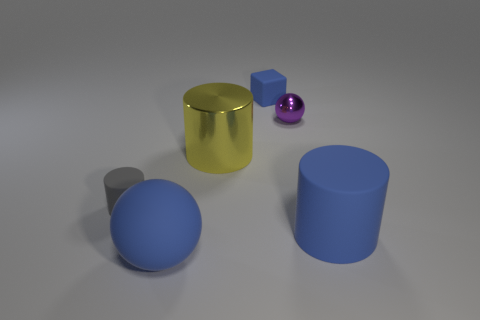Add 1 tiny cylinders. How many objects exist? 7 Subtract all balls. How many objects are left? 4 Subtract all large gray matte balls. Subtract all small shiny objects. How many objects are left? 5 Add 5 blue cubes. How many blue cubes are left? 6 Add 3 big yellow rubber spheres. How many big yellow rubber spheres exist? 3 Subtract 0 red cylinders. How many objects are left? 6 